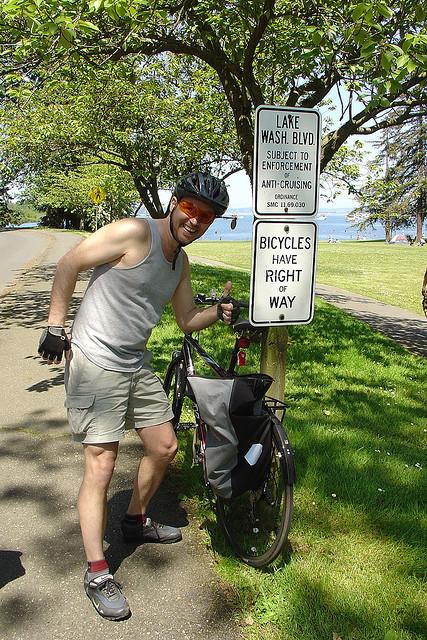What are the signs mounted on?
Keep it brief. Post. Is the man running?
Be succinct. No. According to the sign, what has the right of way on the road?
Short answer required. Bicycles. 